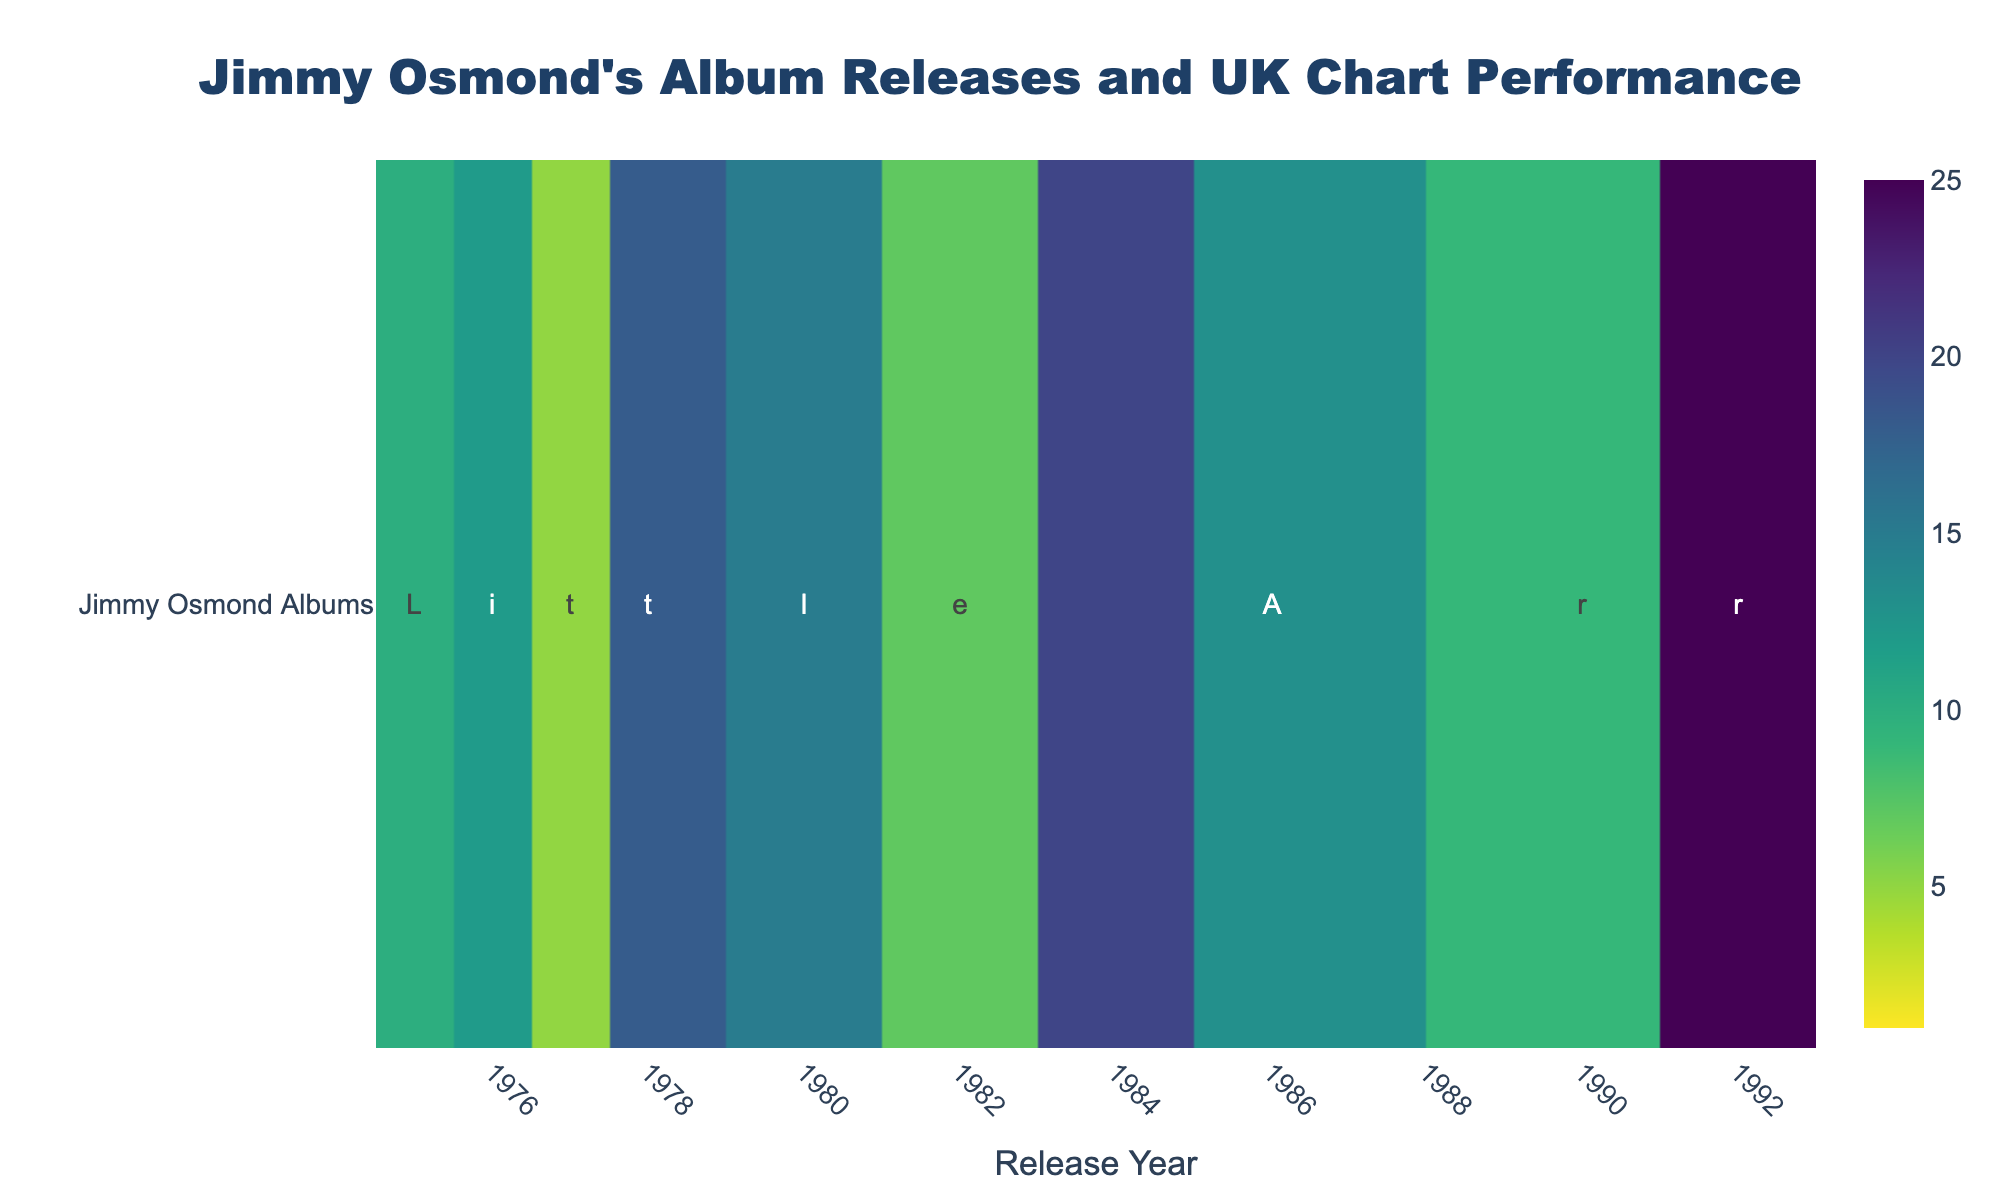What's the title of the heatmap? The title of the heatmap is usually displayed prominently at the top of the figure. By looking at the top center, you can see the text "Jimmy Osmond's Album Releases and UK Chart Performance".
Answer: Jimmy Osmond's Album Releases and UK Chart Performance How many albums are represented in the heatmap? You can count the number of unique pieces of text displayed under each year on the x-axis. There are 10 unique texts, which corresponds to 10 albums.
Answer: 10 Which album had the best UK Chart Position? By identifying the lowest UK Chart Position number in the heatmap, "Mother of Mine" in 1977 has the chart position 5, which is the highest among the others.
Answer: Mother of Mine Which year did "Jimmy Osmond" album get released and what was its chart position? Look for the text "Jimmy Osmond" in the figure; it appears under the "1992" year with a UK Chart Position of 25.
Answer: 1992, 25 What is the average UK Chart Position of Jimmy Osmond's albums throughout the years? To calculate the average, sum all the UK Chart Position values (10 + 12 + 5 + 18 + 15 + 7 + 20 + 13 + 9 + 25 = 134) and divide by the number of albums (10). The average is 134 / 10 = 13.4.
Answer: 13.4 Did any album reach the top 10 UK Chart Positions in the 1980s? Analyze the years 1980s on the x-axis and check the UK Chart Position values. "Always Looking for Love" in 1980 had a position of 15, "Moon River & Me" in 1982 had a position of 7 (which is within top 10), and "Olivia" in 1984 had a position of 20.
Answer: Yes, Moon River & Me in 1982 Which decade had the most albums released by Jimmy Osmond? Check the x-axis years and count the number of albums released in each decade. 1970s: 4 albums, 1980s: 3 albums, 1990s: 2 albums.
Answer: 1970s How does the UK Chart Position of albums vary between the 1970s and the 1990s? Compare the UK Chart Positions for the albums in the 1970s (10, 12, 5, 18) and the 1990s (9, 25). The 1970s had a mix of higher and lower values compared to just two in the 1990s.
Answer: More variability in the 1970s Which album had the lowest UK Chart Position and in which year was it released? Look for the highest numeric value in the heatmap, "Jimmy Osmond" in 1992 had a position of 25, which is the lowest chart position indicating least success.
Answer: Jimmy Osmond, 1992 